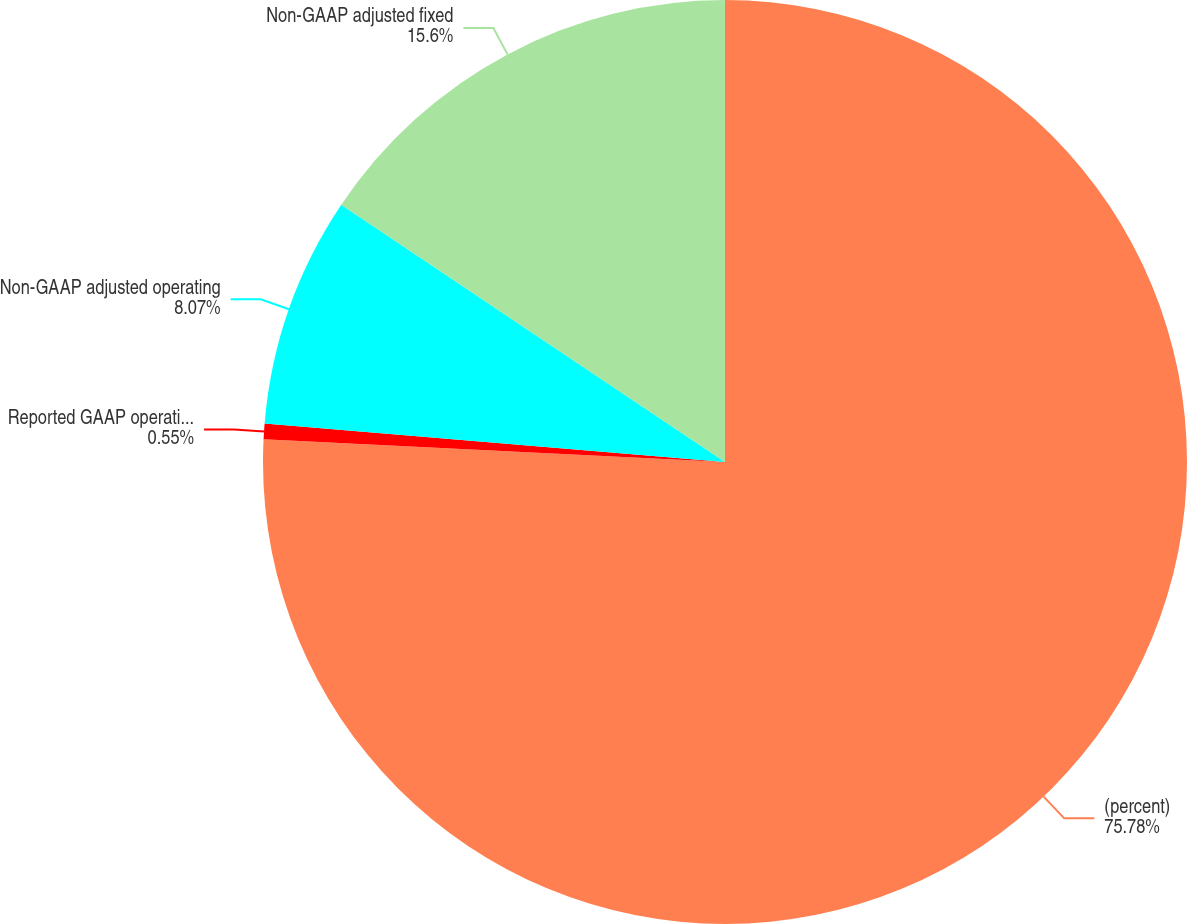Convert chart. <chart><loc_0><loc_0><loc_500><loc_500><pie_chart><fcel>(percent)<fcel>Reported GAAP operating income<fcel>Non-GAAP adjusted operating<fcel>Non-GAAP adjusted fixed<nl><fcel>75.78%<fcel>0.55%<fcel>8.07%<fcel>15.6%<nl></chart> 